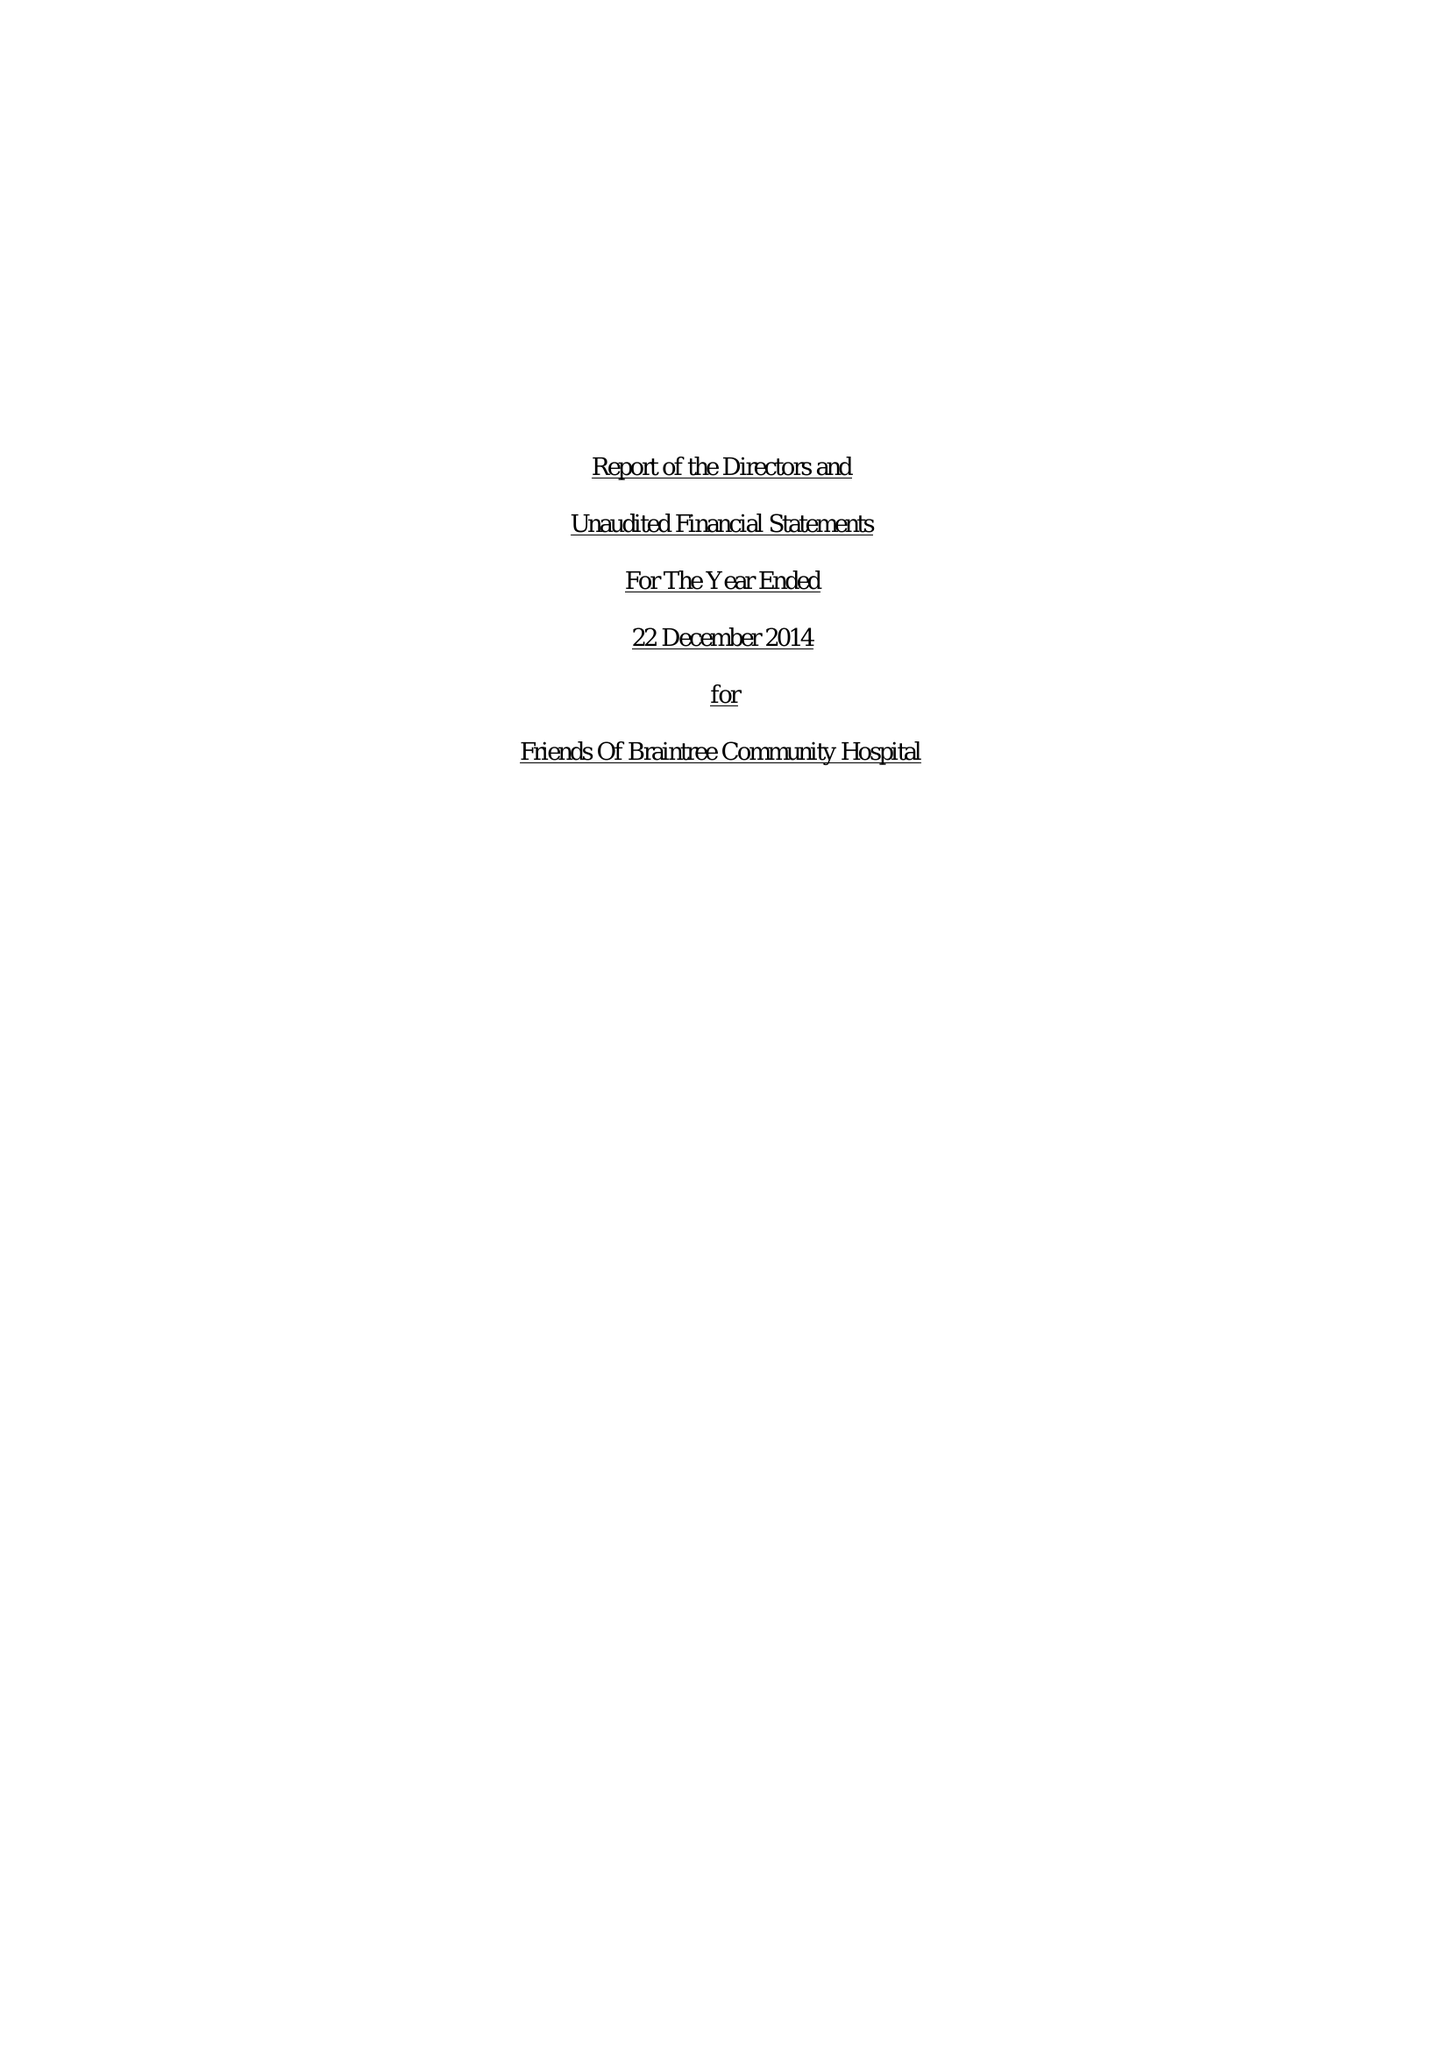What is the value for the address__postcode?
Answer the question using a single word or phrase. CM7 5NT 